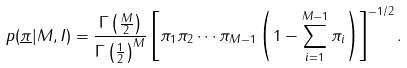<formula> <loc_0><loc_0><loc_500><loc_500>p ( \underline { \pi } | M , I ) = \frac { \Gamma \left ( \frac { M } { 2 } \right ) } { \Gamma \left ( \frac { 1 } { 2 } \right ) ^ { M } } \left [ \pi _ { 1 } \pi _ { 2 } \cdots \pi _ { M - 1 } \left ( 1 - \sum _ { i = 1 } ^ { M - 1 } { \pi _ { i } } \right ) \right ] ^ { - 1 / 2 } .</formula> 